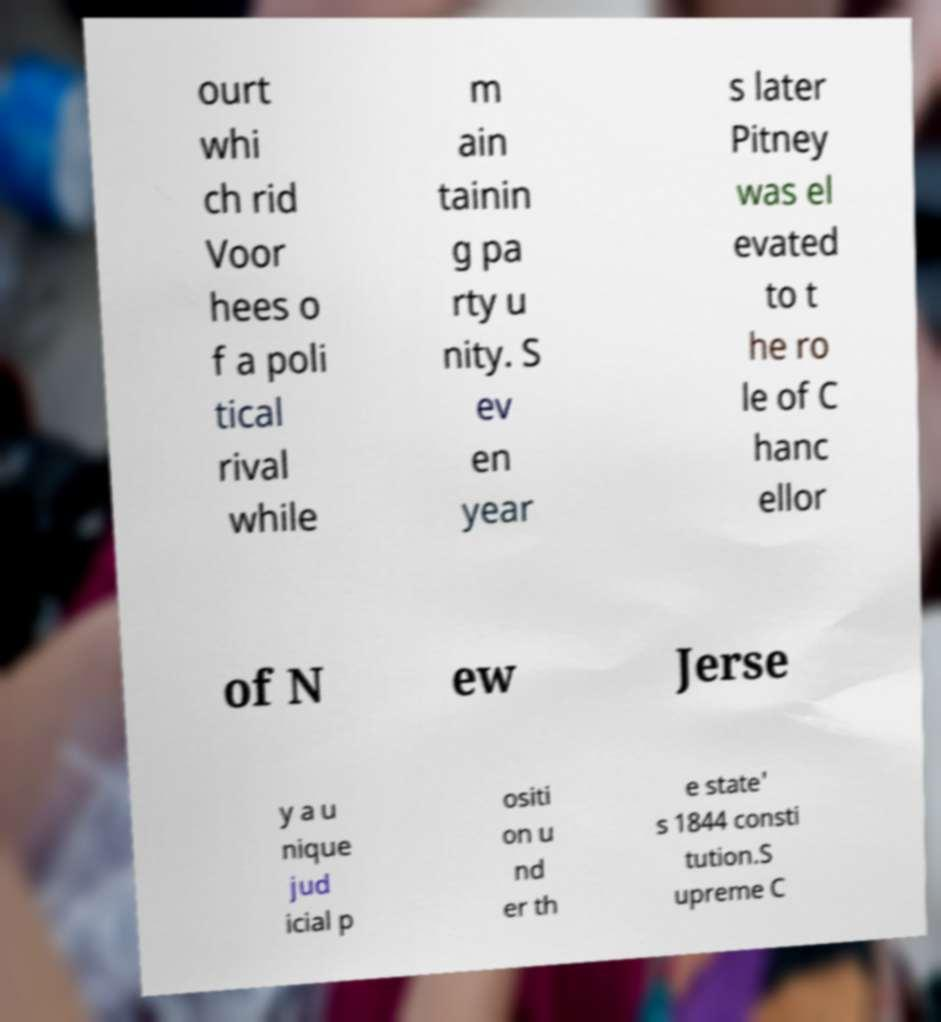Could you extract and type out the text from this image? ourt whi ch rid Voor hees o f a poli tical rival while m ain tainin g pa rty u nity. S ev en year s later Pitney was el evated to t he ro le of C hanc ellor of N ew Jerse y a u nique jud icial p ositi on u nd er th e state' s 1844 consti tution.S upreme C 